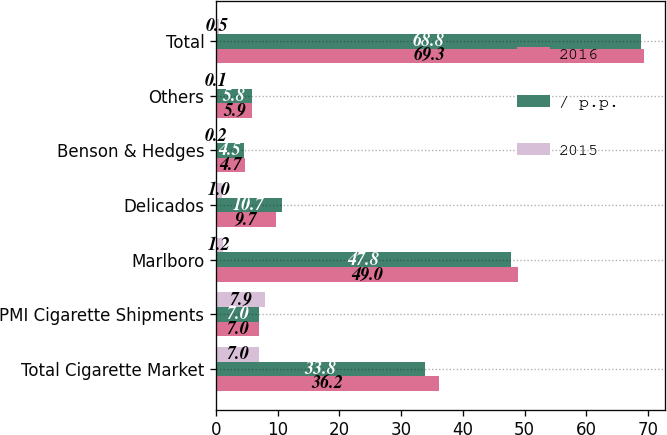Convert chart. <chart><loc_0><loc_0><loc_500><loc_500><stacked_bar_chart><ecel><fcel>Total Cigarette Market<fcel>PMI Cigarette Shipments<fcel>Marlboro<fcel>Delicados<fcel>Benson & Hedges<fcel>Others<fcel>Total<nl><fcel>2016<fcel>36.2<fcel>7<fcel>49<fcel>9.7<fcel>4.7<fcel>5.9<fcel>69.3<nl><fcel>/ p.p.<fcel>33.8<fcel>7<fcel>47.8<fcel>10.7<fcel>4.5<fcel>5.8<fcel>68.8<nl><fcel>2015<fcel>7<fcel>7.9<fcel>1.2<fcel>1<fcel>0.2<fcel>0.1<fcel>0.5<nl></chart> 